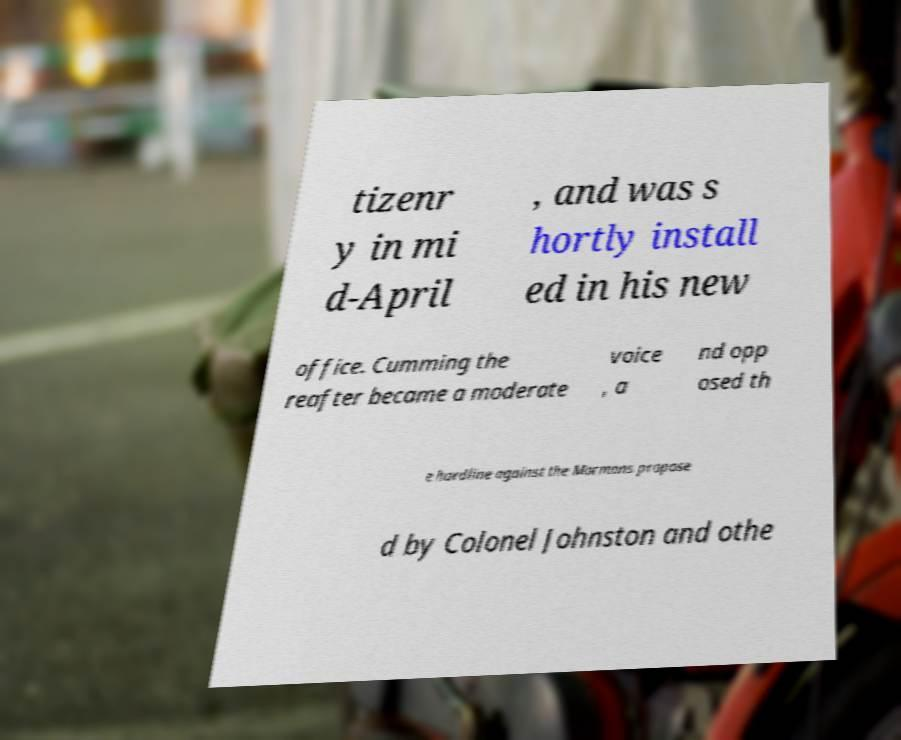For documentation purposes, I need the text within this image transcribed. Could you provide that? tizenr y in mi d-April , and was s hortly install ed in his new office. Cumming the reafter became a moderate voice , a nd opp osed th e hardline against the Mormons propose d by Colonel Johnston and othe 